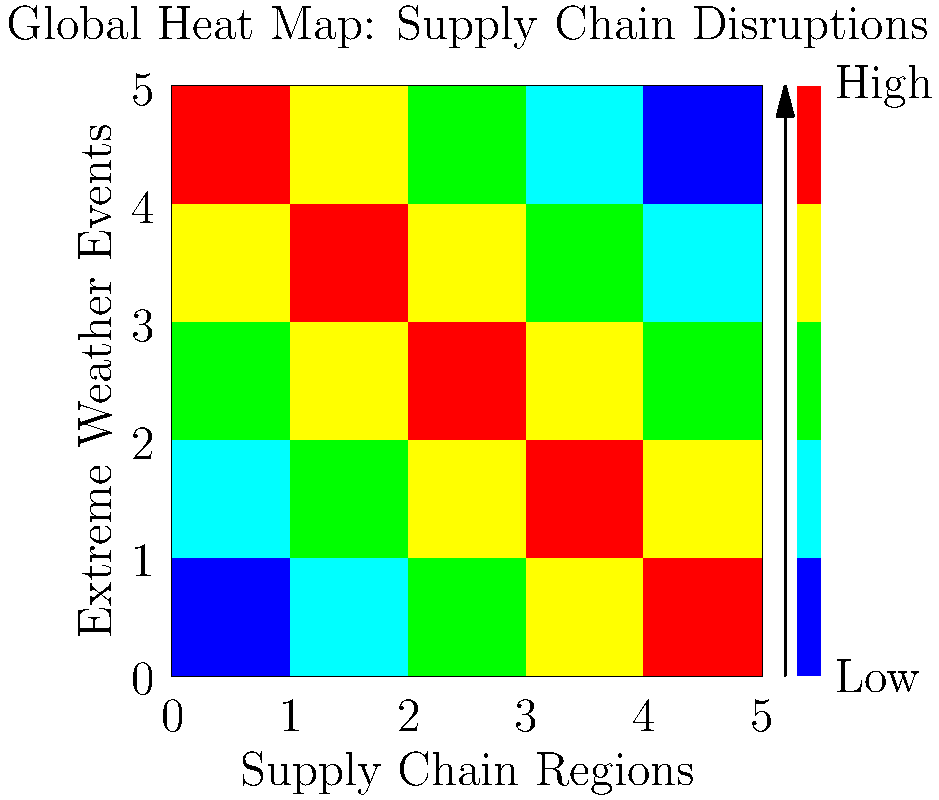Based on the global heat map showing the impact of extreme weather events on supply chain disruptions, which region appears to be most vulnerable to climate-related risks, and what strategy would you recommend to a corporation operating in this area to mitigate potential financial losses? To answer this question, we need to analyze the heat map and interpret its implications:

1. Interpret the heat map:
   - The x-axis represents different supply chain regions.
   - The y-axis represents types of extreme weather events.
   - The color intensity indicates the severity of disruptions (blue: low, red: high).

2. Identify the most vulnerable region:
   - The top-left corner of the map shows the highest concentration of red squares.
   - This indicates that the leftmost region on the x-axis is most vulnerable to various extreme weather events.

3. Assess the climate-related risks:
   - The region faces high disruption risks across multiple types of extreme weather events.
   - This suggests a need for comprehensive climate risk management strategies.

4. Recommend a strategy to mitigate financial losses:
   a) Diversification of suppliers: Reduce dependency on the high-risk region by establishing alternative suppliers in less vulnerable areas.
   b) Investment in resilient infrastructure: Strengthen existing facilities to withstand extreme weather events.
   c) Implementation of early warning systems: Develop or enhance systems to predict and prepare for incoming extreme weather events.
   d) Climate risk insurance: Obtain specialized insurance coverage for climate-related disruptions.
   e) Scenario planning: Develop and regularly update contingency plans for various climate-related disruptions.

5. Financial implications:
   - These strategies require upfront investments but can significantly reduce long-term financial losses from supply chain disruptions.
   - They also position the corporation as proactive in addressing climate risks, potentially improving stakeholder relations and market position.

The most effective strategy would be a combination of these approaches, tailored to the specific needs and resources of the corporation. However, for a concise answer, we'll focus on the most immediately impactful strategy.
Answer: Diversify suppliers to less vulnerable regions; implement comprehensive climate risk management strategies including resilient infrastructure and early warning systems. 